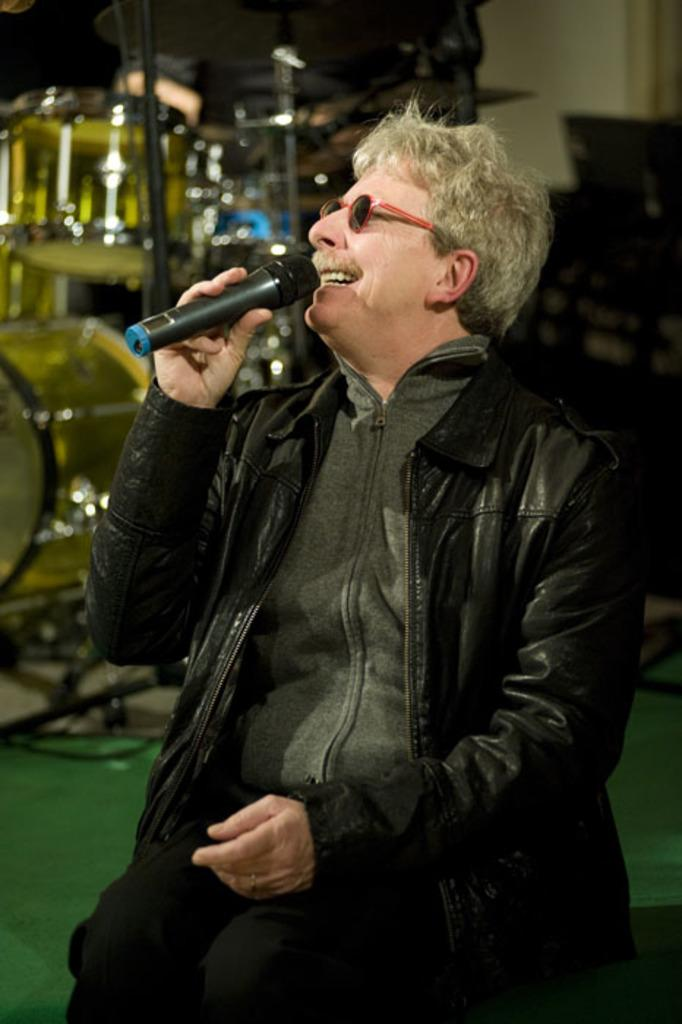What is the man in the image doing? The man is sitting in the image. What object is the man holding in his hand? The man is holding a microphone in his hand. What musical instrument can be seen in the background of the image? There are drums in the background of the image. Is there an umbrella being used to shield the man from the wind in the image? There is no umbrella or wind present in the image. When was the man's birth, as depicted in the image? The image does not provide information about the man's birth. 